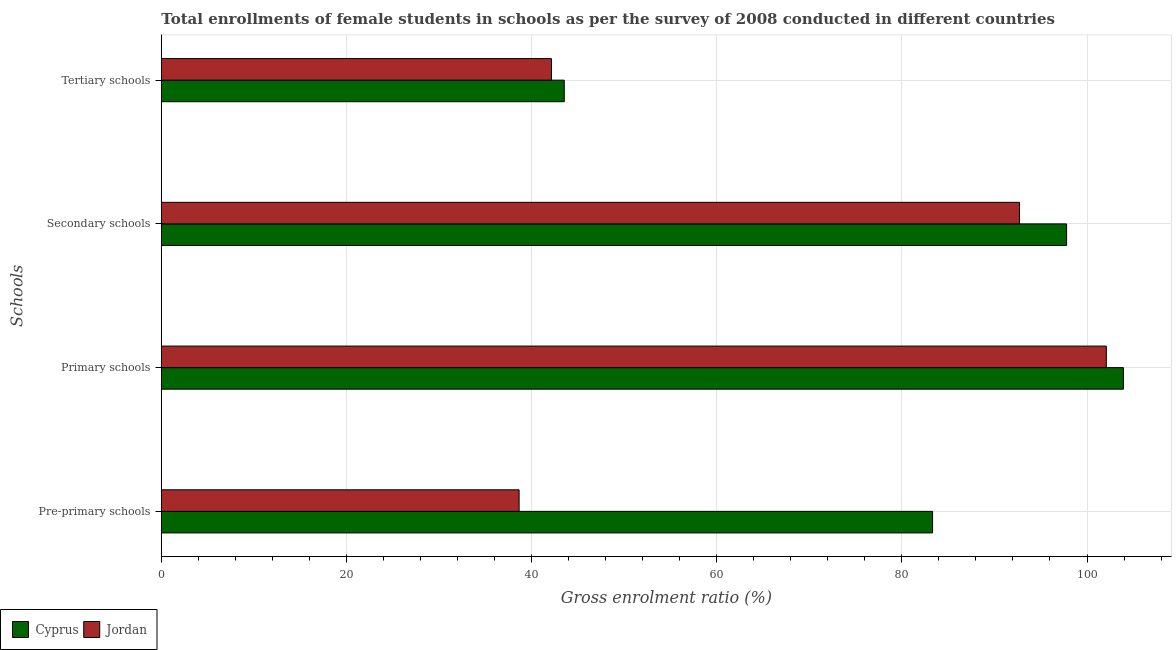Are the number of bars per tick equal to the number of legend labels?
Offer a terse response. Yes. Are the number of bars on each tick of the Y-axis equal?
Keep it short and to the point. Yes. How many bars are there on the 2nd tick from the top?
Ensure brevity in your answer.  2. How many bars are there on the 1st tick from the bottom?
Your response must be concise. 2. What is the label of the 1st group of bars from the top?
Give a very brief answer. Tertiary schools. What is the gross enrolment ratio(female) in tertiary schools in Jordan?
Your answer should be very brief. 42.15. Across all countries, what is the maximum gross enrolment ratio(female) in primary schools?
Ensure brevity in your answer.  103.93. Across all countries, what is the minimum gross enrolment ratio(female) in tertiary schools?
Keep it short and to the point. 42.15. In which country was the gross enrolment ratio(female) in pre-primary schools maximum?
Your answer should be compact. Cyprus. In which country was the gross enrolment ratio(female) in pre-primary schools minimum?
Provide a short and direct response. Jordan. What is the total gross enrolment ratio(female) in tertiary schools in the graph?
Make the answer very short. 85.67. What is the difference between the gross enrolment ratio(female) in pre-primary schools in Jordan and that in Cyprus?
Ensure brevity in your answer.  -44.67. What is the difference between the gross enrolment ratio(female) in pre-primary schools in Jordan and the gross enrolment ratio(female) in primary schools in Cyprus?
Provide a succinct answer. -65.28. What is the average gross enrolment ratio(female) in tertiary schools per country?
Ensure brevity in your answer.  42.84. What is the difference between the gross enrolment ratio(female) in secondary schools and gross enrolment ratio(female) in tertiary schools in Cyprus?
Make the answer very short. 54.27. What is the ratio of the gross enrolment ratio(female) in primary schools in Jordan to that in Cyprus?
Give a very brief answer. 0.98. What is the difference between the highest and the second highest gross enrolment ratio(female) in secondary schools?
Offer a very short reply. 5.09. What is the difference between the highest and the lowest gross enrolment ratio(female) in secondary schools?
Keep it short and to the point. 5.09. In how many countries, is the gross enrolment ratio(female) in pre-primary schools greater than the average gross enrolment ratio(female) in pre-primary schools taken over all countries?
Offer a terse response. 1. Is it the case that in every country, the sum of the gross enrolment ratio(female) in primary schools and gross enrolment ratio(female) in secondary schools is greater than the sum of gross enrolment ratio(female) in pre-primary schools and gross enrolment ratio(female) in tertiary schools?
Provide a succinct answer. Yes. What does the 1st bar from the top in Secondary schools represents?
Keep it short and to the point. Jordan. What does the 1st bar from the bottom in Primary schools represents?
Provide a succinct answer. Cyprus. Are all the bars in the graph horizontal?
Ensure brevity in your answer.  Yes. What is the difference between two consecutive major ticks on the X-axis?
Offer a very short reply. 20. Does the graph contain any zero values?
Make the answer very short. No. Does the graph contain grids?
Offer a very short reply. Yes. Where does the legend appear in the graph?
Provide a succinct answer. Bottom left. What is the title of the graph?
Offer a terse response. Total enrollments of female students in schools as per the survey of 2008 conducted in different countries. Does "Latin America(all income levels)" appear as one of the legend labels in the graph?
Keep it short and to the point. No. What is the label or title of the Y-axis?
Your response must be concise. Schools. What is the Gross enrolment ratio (%) in Cyprus in Pre-primary schools?
Make the answer very short. 83.32. What is the Gross enrolment ratio (%) of Jordan in Pre-primary schools?
Keep it short and to the point. 38.65. What is the Gross enrolment ratio (%) in Cyprus in Primary schools?
Your response must be concise. 103.93. What is the Gross enrolment ratio (%) of Jordan in Primary schools?
Make the answer very short. 102.09. What is the Gross enrolment ratio (%) in Cyprus in Secondary schools?
Give a very brief answer. 97.8. What is the Gross enrolment ratio (%) of Jordan in Secondary schools?
Ensure brevity in your answer.  92.71. What is the Gross enrolment ratio (%) in Cyprus in Tertiary schools?
Provide a short and direct response. 43.53. What is the Gross enrolment ratio (%) in Jordan in Tertiary schools?
Your answer should be very brief. 42.15. Across all Schools, what is the maximum Gross enrolment ratio (%) of Cyprus?
Offer a terse response. 103.93. Across all Schools, what is the maximum Gross enrolment ratio (%) of Jordan?
Ensure brevity in your answer.  102.09. Across all Schools, what is the minimum Gross enrolment ratio (%) of Cyprus?
Make the answer very short. 43.53. Across all Schools, what is the minimum Gross enrolment ratio (%) of Jordan?
Your answer should be compact. 38.65. What is the total Gross enrolment ratio (%) of Cyprus in the graph?
Keep it short and to the point. 328.57. What is the total Gross enrolment ratio (%) of Jordan in the graph?
Provide a short and direct response. 275.59. What is the difference between the Gross enrolment ratio (%) in Cyprus in Pre-primary schools and that in Primary schools?
Your answer should be compact. -20.61. What is the difference between the Gross enrolment ratio (%) in Jordan in Pre-primary schools and that in Primary schools?
Provide a short and direct response. -63.44. What is the difference between the Gross enrolment ratio (%) in Cyprus in Pre-primary schools and that in Secondary schools?
Your answer should be very brief. -14.48. What is the difference between the Gross enrolment ratio (%) of Jordan in Pre-primary schools and that in Secondary schools?
Keep it short and to the point. -54.06. What is the difference between the Gross enrolment ratio (%) in Cyprus in Pre-primary schools and that in Tertiary schools?
Offer a very short reply. 39.79. What is the difference between the Gross enrolment ratio (%) of Jordan in Pre-primary schools and that in Tertiary schools?
Keep it short and to the point. -3.49. What is the difference between the Gross enrolment ratio (%) of Cyprus in Primary schools and that in Secondary schools?
Provide a short and direct response. 6.13. What is the difference between the Gross enrolment ratio (%) of Jordan in Primary schools and that in Secondary schools?
Provide a short and direct response. 9.38. What is the difference between the Gross enrolment ratio (%) of Cyprus in Primary schools and that in Tertiary schools?
Keep it short and to the point. 60.4. What is the difference between the Gross enrolment ratio (%) in Jordan in Primary schools and that in Tertiary schools?
Offer a very short reply. 59.94. What is the difference between the Gross enrolment ratio (%) of Cyprus in Secondary schools and that in Tertiary schools?
Offer a very short reply. 54.27. What is the difference between the Gross enrolment ratio (%) in Jordan in Secondary schools and that in Tertiary schools?
Provide a short and direct response. 50.56. What is the difference between the Gross enrolment ratio (%) of Cyprus in Pre-primary schools and the Gross enrolment ratio (%) of Jordan in Primary schools?
Ensure brevity in your answer.  -18.77. What is the difference between the Gross enrolment ratio (%) in Cyprus in Pre-primary schools and the Gross enrolment ratio (%) in Jordan in Secondary schools?
Provide a short and direct response. -9.39. What is the difference between the Gross enrolment ratio (%) in Cyprus in Pre-primary schools and the Gross enrolment ratio (%) in Jordan in Tertiary schools?
Your answer should be compact. 41.17. What is the difference between the Gross enrolment ratio (%) of Cyprus in Primary schools and the Gross enrolment ratio (%) of Jordan in Secondary schools?
Offer a terse response. 11.22. What is the difference between the Gross enrolment ratio (%) of Cyprus in Primary schools and the Gross enrolment ratio (%) of Jordan in Tertiary schools?
Give a very brief answer. 61.79. What is the difference between the Gross enrolment ratio (%) of Cyprus in Secondary schools and the Gross enrolment ratio (%) of Jordan in Tertiary schools?
Provide a short and direct response. 55.65. What is the average Gross enrolment ratio (%) in Cyprus per Schools?
Give a very brief answer. 82.14. What is the average Gross enrolment ratio (%) of Jordan per Schools?
Make the answer very short. 68.9. What is the difference between the Gross enrolment ratio (%) in Cyprus and Gross enrolment ratio (%) in Jordan in Pre-primary schools?
Keep it short and to the point. 44.67. What is the difference between the Gross enrolment ratio (%) of Cyprus and Gross enrolment ratio (%) of Jordan in Primary schools?
Your answer should be very brief. 1.84. What is the difference between the Gross enrolment ratio (%) in Cyprus and Gross enrolment ratio (%) in Jordan in Secondary schools?
Offer a terse response. 5.09. What is the difference between the Gross enrolment ratio (%) in Cyprus and Gross enrolment ratio (%) in Jordan in Tertiary schools?
Your answer should be compact. 1.38. What is the ratio of the Gross enrolment ratio (%) of Cyprus in Pre-primary schools to that in Primary schools?
Offer a very short reply. 0.8. What is the ratio of the Gross enrolment ratio (%) in Jordan in Pre-primary schools to that in Primary schools?
Offer a very short reply. 0.38. What is the ratio of the Gross enrolment ratio (%) in Cyprus in Pre-primary schools to that in Secondary schools?
Provide a short and direct response. 0.85. What is the ratio of the Gross enrolment ratio (%) in Jordan in Pre-primary schools to that in Secondary schools?
Provide a succinct answer. 0.42. What is the ratio of the Gross enrolment ratio (%) of Cyprus in Pre-primary schools to that in Tertiary schools?
Keep it short and to the point. 1.91. What is the ratio of the Gross enrolment ratio (%) of Jordan in Pre-primary schools to that in Tertiary schools?
Keep it short and to the point. 0.92. What is the ratio of the Gross enrolment ratio (%) of Cyprus in Primary schools to that in Secondary schools?
Your response must be concise. 1.06. What is the ratio of the Gross enrolment ratio (%) in Jordan in Primary schools to that in Secondary schools?
Your answer should be compact. 1.1. What is the ratio of the Gross enrolment ratio (%) in Cyprus in Primary schools to that in Tertiary schools?
Offer a very short reply. 2.39. What is the ratio of the Gross enrolment ratio (%) of Jordan in Primary schools to that in Tertiary schools?
Offer a terse response. 2.42. What is the ratio of the Gross enrolment ratio (%) in Cyprus in Secondary schools to that in Tertiary schools?
Your answer should be compact. 2.25. What is the ratio of the Gross enrolment ratio (%) in Jordan in Secondary schools to that in Tertiary schools?
Keep it short and to the point. 2.2. What is the difference between the highest and the second highest Gross enrolment ratio (%) in Cyprus?
Keep it short and to the point. 6.13. What is the difference between the highest and the second highest Gross enrolment ratio (%) in Jordan?
Offer a very short reply. 9.38. What is the difference between the highest and the lowest Gross enrolment ratio (%) of Cyprus?
Provide a succinct answer. 60.4. What is the difference between the highest and the lowest Gross enrolment ratio (%) in Jordan?
Your answer should be very brief. 63.44. 